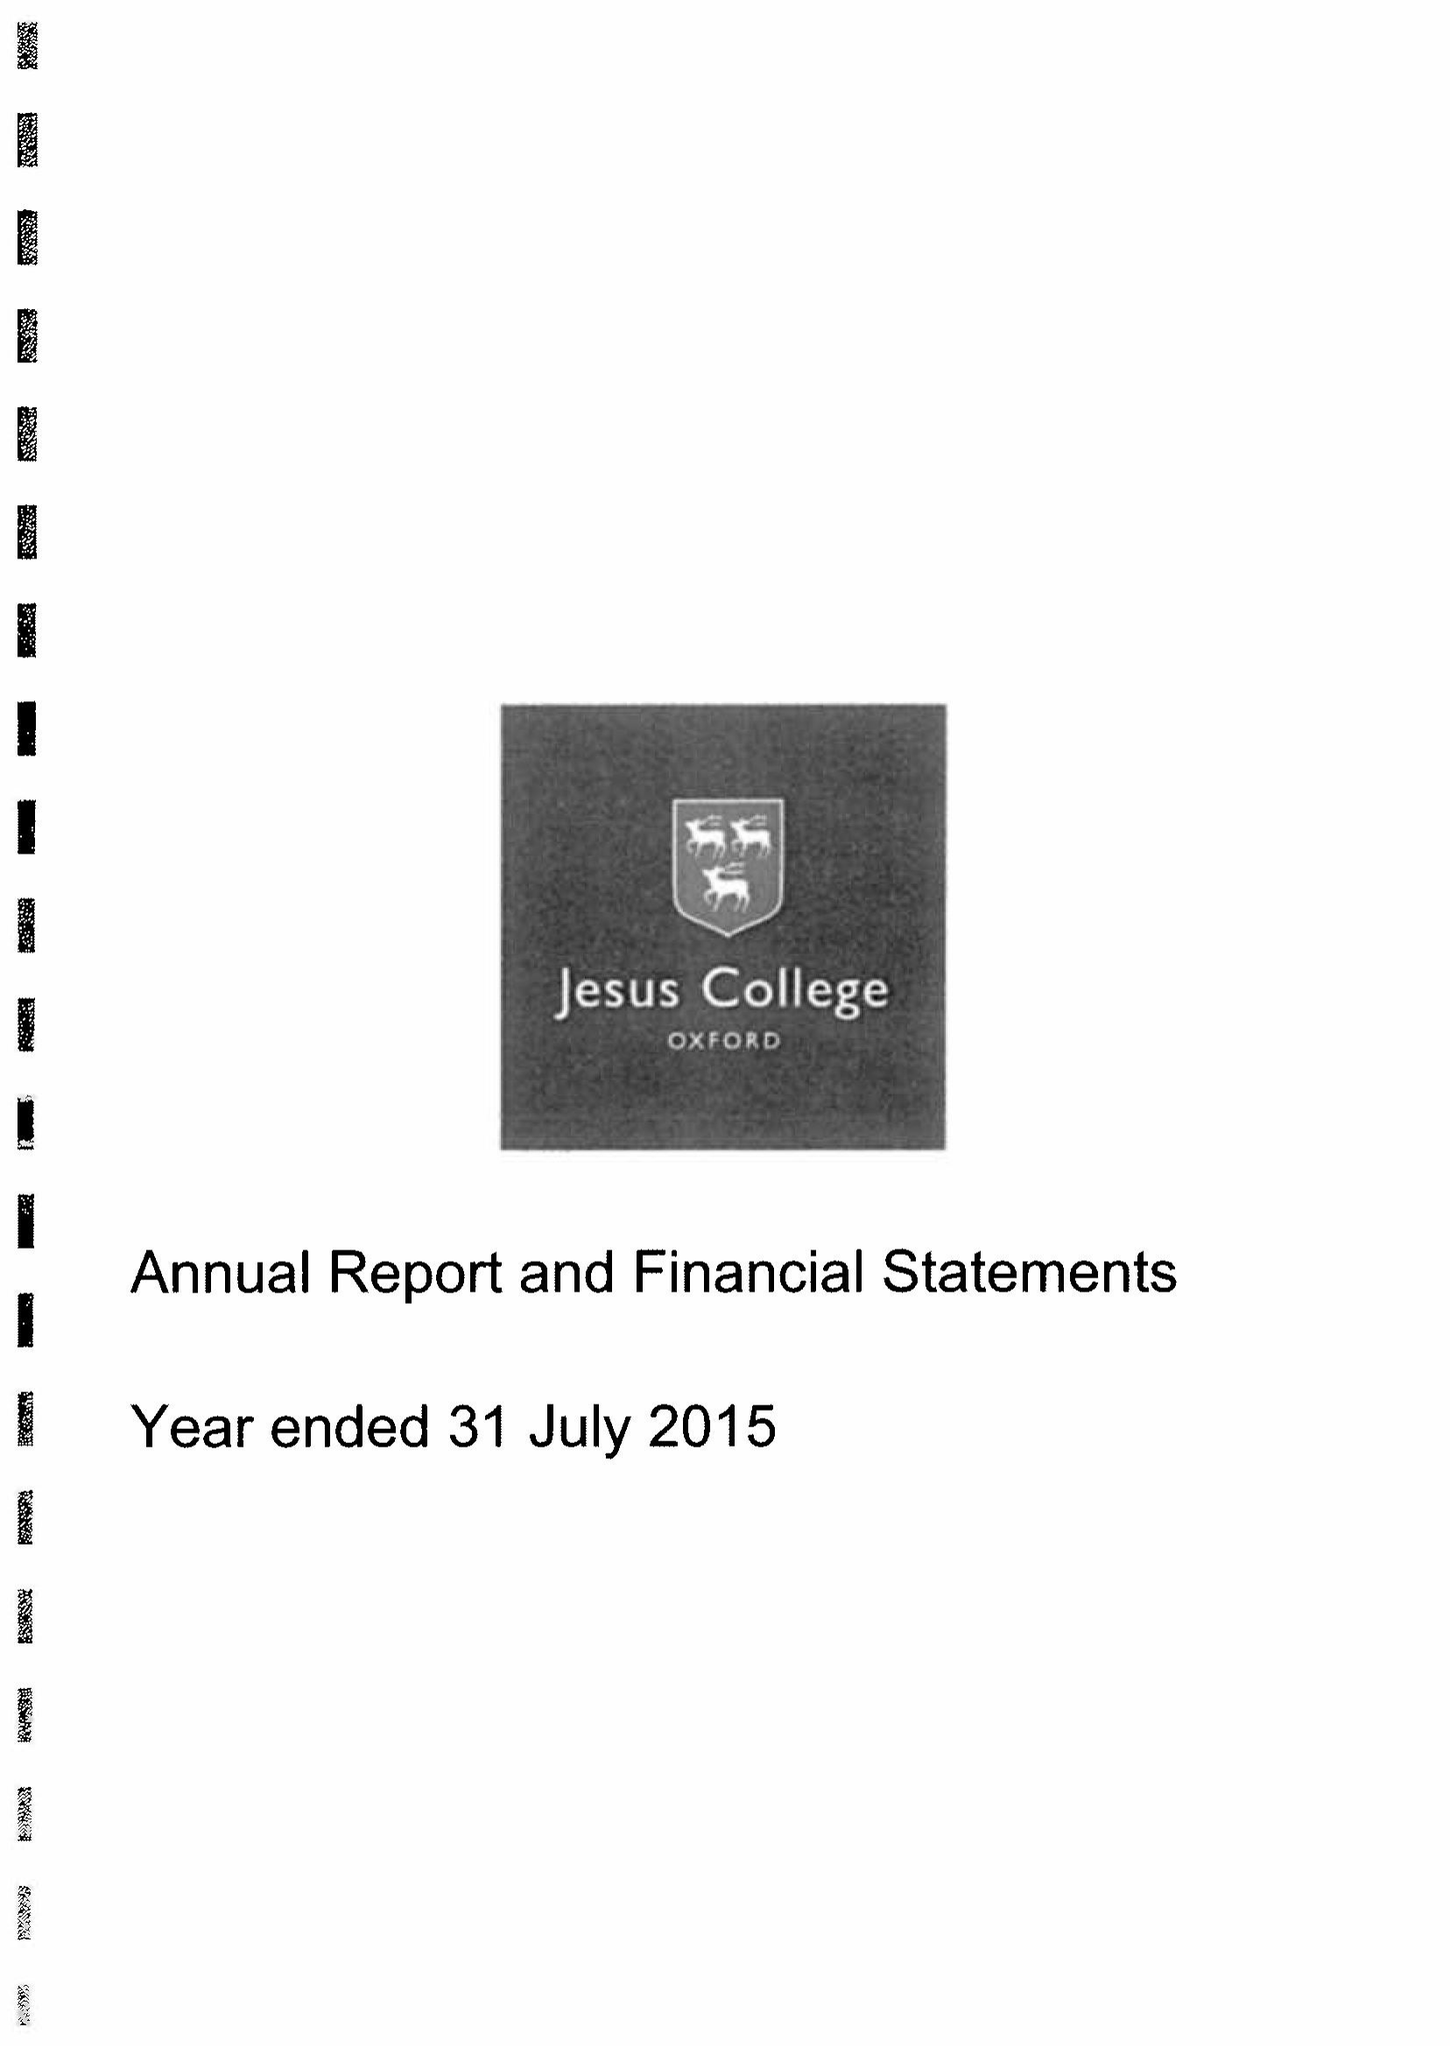What is the value for the address__street_line?
Answer the question using a single word or phrase. TURL STREET 